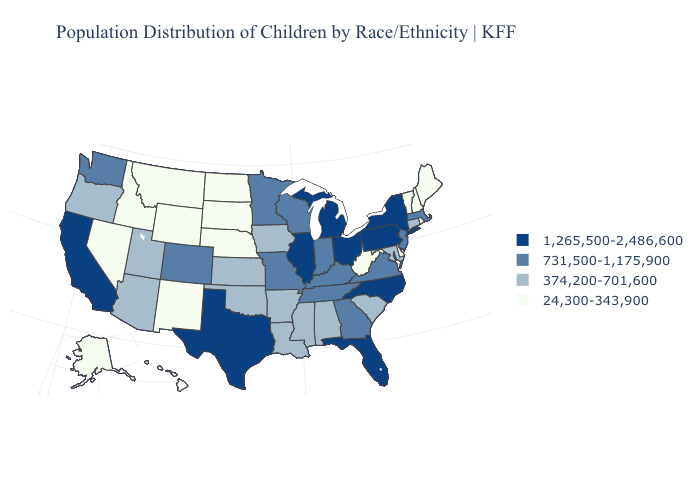Does Michigan have the highest value in the MidWest?
Write a very short answer. Yes. What is the lowest value in states that border Utah?
Quick response, please. 24,300-343,900. Does New York have the highest value in the USA?
Be succinct. Yes. Name the states that have a value in the range 374,200-701,600?
Give a very brief answer. Alabama, Arizona, Arkansas, Connecticut, Iowa, Kansas, Louisiana, Maryland, Mississippi, Oklahoma, Oregon, South Carolina, Utah. Does New Hampshire have the lowest value in the USA?
Give a very brief answer. Yes. Does the map have missing data?
Write a very short answer. No. Name the states that have a value in the range 1,265,500-2,486,600?
Be succinct. California, Florida, Illinois, Michigan, New York, North Carolina, Ohio, Pennsylvania, Texas. What is the value of Delaware?
Give a very brief answer. 24,300-343,900. What is the lowest value in states that border Kentucky?
Answer briefly. 24,300-343,900. What is the value of Colorado?
Answer briefly. 731,500-1,175,900. What is the highest value in the USA?
Write a very short answer. 1,265,500-2,486,600. What is the value of Washington?
Write a very short answer. 731,500-1,175,900. Which states have the lowest value in the West?
Quick response, please. Alaska, Hawaii, Idaho, Montana, Nevada, New Mexico, Wyoming. Which states hav the highest value in the West?
Keep it brief. California. Name the states that have a value in the range 731,500-1,175,900?
Be succinct. Colorado, Georgia, Indiana, Kentucky, Massachusetts, Minnesota, Missouri, New Jersey, Tennessee, Virginia, Washington, Wisconsin. 